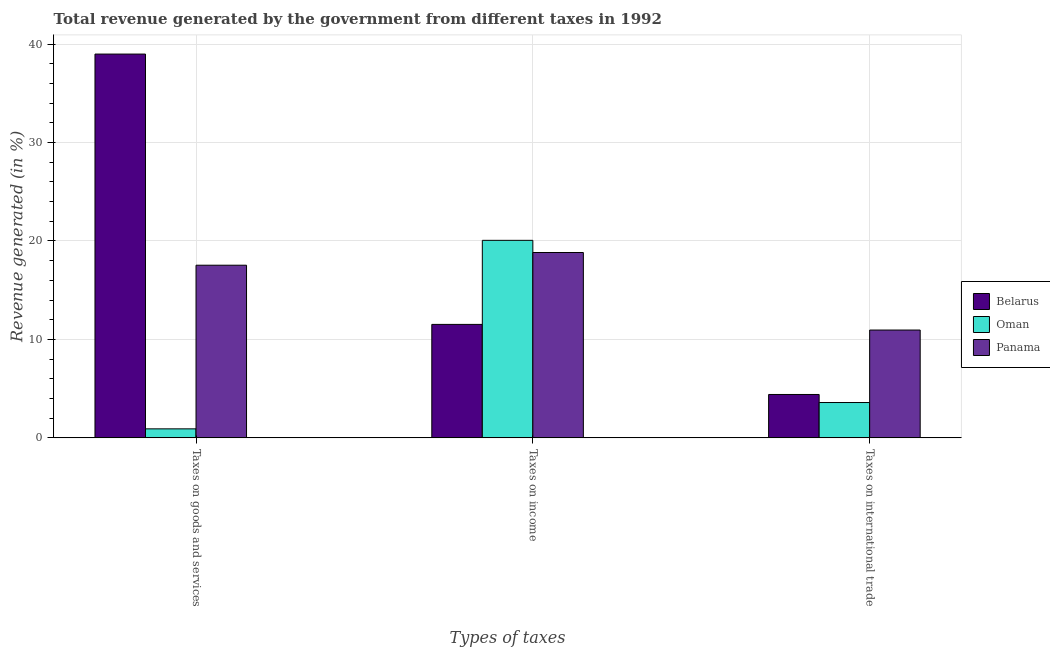How many groups of bars are there?
Make the answer very short. 3. Are the number of bars per tick equal to the number of legend labels?
Ensure brevity in your answer.  Yes. Are the number of bars on each tick of the X-axis equal?
Provide a succinct answer. Yes. What is the label of the 1st group of bars from the left?
Make the answer very short. Taxes on goods and services. What is the percentage of revenue generated by taxes on goods and services in Belarus?
Keep it short and to the point. 38.98. Across all countries, what is the maximum percentage of revenue generated by taxes on income?
Ensure brevity in your answer.  20.06. Across all countries, what is the minimum percentage of revenue generated by taxes on goods and services?
Keep it short and to the point. 0.92. In which country was the percentage of revenue generated by taxes on goods and services maximum?
Give a very brief answer. Belarus. In which country was the percentage of revenue generated by tax on international trade minimum?
Give a very brief answer. Oman. What is the total percentage of revenue generated by tax on international trade in the graph?
Provide a succinct answer. 18.95. What is the difference between the percentage of revenue generated by taxes on goods and services in Belarus and that in Panama?
Your answer should be compact. 21.45. What is the difference between the percentage of revenue generated by taxes on goods and services in Oman and the percentage of revenue generated by tax on international trade in Panama?
Give a very brief answer. -10.04. What is the average percentage of revenue generated by taxes on income per country?
Give a very brief answer. 16.81. What is the difference between the percentage of revenue generated by taxes on goods and services and percentage of revenue generated by tax on international trade in Oman?
Keep it short and to the point. -2.67. What is the ratio of the percentage of revenue generated by taxes on goods and services in Oman to that in Panama?
Give a very brief answer. 0.05. Is the difference between the percentage of revenue generated by taxes on goods and services in Belarus and Oman greater than the difference between the percentage of revenue generated by tax on international trade in Belarus and Oman?
Keep it short and to the point. Yes. What is the difference between the highest and the second highest percentage of revenue generated by taxes on income?
Offer a terse response. 1.24. What is the difference between the highest and the lowest percentage of revenue generated by tax on international trade?
Offer a terse response. 7.36. Is the sum of the percentage of revenue generated by tax on international trade in Oman and Panama greater than the maximum percentage of revenue generated by taxes on income across all countries?
Make the answer very short. No. What does the 3rd bar from the left in Taxes on international trade represents?
Make the answer very short. Panama. What does the 2nd bar from the right in Taxes on international trade represents?
Your answer should be very brief. Oman. What is the difference between two consecutive major ticks on the Y-axis?
Give a very brief answer. 10. Are the values on the major ticks of Y-axis written in scientific E-notation?
Your answer should be very brief. No. Does the graph contain grids?
Provide a short and direct response. Yes. How many legend labels are there?
Your response must be concise. 3. How are the legend labels stacked?
Make the answer very short. Vertical. What is the title of the graph?
Ensure brevity in your answer.  Total revenue generated by the government from different taxes in 1992. What is the label or title of the X-axis?
Provide a short and direct response. Types of taxes. What is the label or title of the Y-axis?
Offer a terse response. Revenue generated (in %). What is the Revenue generated (in %) of Belarus in Taxes on goods and services?
Make the answer very short. 38.98. What is the Revenue generated (in %) of Oman in Taxes on goods and services?
Ensure brevity in your answer.  0.92. What is the Revenue generated (in %) of Panama in Taxes on goods and services?
Ensure brevity in your answer.  17.54. What is the Revenue generated (in %) of Belarus in Taxes on income?
Provide a succinct answer. 11.53. What is the Revenue generated (in %) in Oman in Taxes on income?
Ensure brevity in your answer.  20.06. What is the Revenue generated (in %) in Panama in Taxes on income?
Provide a short and direct response. 18.83. What is the Revenue generated (in %) of Belarus in Taxes on international trade?
Your answer should be compact. 4.41. What is the Revenue generated (in %) in Oman in Taxes on international trade?
Keep it short and to the point. 3.59. What is the Revenue generated (in %) of Panama in Taxes on international trade?
Provide a succinct answer. 10.95. Across all Types of taxes, what is the maximum Revenue generated (in %) of Belarus?
Keep it short and to the point. 38.98. Across all Types of taxes, what is the maximum Revenue generated (in %) in Oman?
Provide a short and direct response. 20.06. Across all Types of taxes, what is the maximum Revenue generated (in %) in Panama?
Provide a short and direct response. 18.83. Across all Types of taxes, what is the minimum Revenue generated (in %) in Belarus?
Your answer should be very brief. 4.41. Across all Types of taxes, what is the minimum Revenue generated (in %) in Oman?
Provide a short and direct response. 0.92. Across all Types of taxes, what is the minimum Revenue generated (in %) in Panama?
Your answer should be compact. 10.95. What is the total Revenue generated (in %) in Belarus in the graph?
Your response must be concise. 54.92. What is the total Revenue generated (in %) in Oman in the graph?
Offer a very short reply. 24.57. What is the total Revenue generated (in %) in Panama in the graph?
Your response must be concise. 47.32. What is the difference between the Revenue generated (in %) of Belarus in Taxes on goods and services and that in Taxes on income?
Provide a succinct answer. 27.46. What is the difference between the Revenue generated (in %) of Oman in Taxes on goods and services and that in Taxes on income?
Your answer should be compact. -19.15. What is the difference between the Revenue generated (in %) in Panama in Taxes on goods and services and that in Taxes on income?
Make the answer very short. -1.29. What is the difference between the Revenue generated (in %) of Belarus in Taxes on goods and services and that in Taxes on international trade?
Offer a terse response. 34.58. What is the difference between the Revenue generated (in %) of Oman in Taxes on goods and services and that in Taxes on international trade?
Provide a short and direct response. -2.67. What is the difference between the Revenue generated (in %) of Panama in Taxes on goods and services and that in Taxes on international trade?
Ensure brevity in your answer.  6.58. What is the difference between the Revenue generated (in %) of Belarus in Taxes on income and that in Taxes on international trade?
Give a very brief answer. 7.12. What is the difference between the Revenue generated (in %) of Oman in Taxes on income and that in Taxes on international trade?
Provide a short and direct response. 16.47. What is the difference between the Revenue generated (in %) of Panama in Taxes on income and that in Taxes on international trade?
Your answer should be very brief. 7.87. What is the difference between the Revenue generated (in %) in Belarus in Taxes on goods and services and the Revenue generated (in %) in Oman in Taxes on income?
Your answer should be very brief. 18.92. What is the difference between the Revenue generated (in %) in Belarus in Taxes on goods and services and the Revenue generated (in %) in Panama in Taxes on income?
Offer a terse response. 20.16. What is the difference between the Revenue generated (in %) of Oman in Taxes on goods and services and the Revenue generated (in %) of Panama in Taxes on income?
Provide a succinct answer. -17.91. What is the difference between the Revenue generated (in %) in Belarus in Taxes on goods and services and the Revenue generated (in %) in Oman in Taxes on international trade?
Your response must be concise. 35.39. What is the difference between the Revenue generated (in %) in Belarus in Taxes on goods and services and the Revenue generated (in %) in Panama in Taxes on international trade?
Your answer should be compact. 28.03. What is the difference between the Revenue generated (in %) of Oman in Taxes on goods and services and the Revenue generated (in %) of Panama in Taxes on international trade?
Ensure brevity in your answer.  -10.04. What is the difference between the Revenue generated (in %) in Belarus in Taxes on income and the Revenue generated (in %) in Oman in Taxes on international trade?
Provide a short and direct response. 7.93. What is the difference between the Revenue generated (in %) in Belarus in Taxes on income and the Revenue generated (in %) in Panama in Taxes on international trade?
Your response must be concise. 0.57. What is the difference between the Revenue generated (in %) of Oman in Taxes on income and the Revenue generated (in %) of Panama in Taxes on international trade?
Ensure brevity in your answer.  9.11. What is the average Revenue generated (in %) in Belarus per Types of taxes?
Give a very brief answer. 18.31. What is the average Revenue generated (in %) of Oman per Types of taxes?
Give a very brief answer. 8.19. What is the average Revenue generated (in %) of Panama per Types of taxes?
Offer a very short reply. 15.77. What is the difference between the Revenue generated (in %) in Belarus and Revenue generated (in %) in Oman in Taxes on goods and services?
Offer a very short reply. 38.07. What is the difference between the Revenue generated (in %) of Belarus and Revenue generated (in %) of Panama in Taxes on goods and services?
Provide a succinct answer. 21.45. What is the difference between the Revenue generated (in %) of Oman and Revenue generated (in %) of Panama in Taxes on goods and services?
Provide a short and direct response. -16.62. What is the difference between the Revenue generated (in %) of Belarus and Revenue generated (in %) of Oman in Taxes on income?
Provide a short and direct response. -8.54. What is the difference between the Revenue generated (in %) in Belarus and Revenue generated (in %) in Panama in Taxes on income?
Provide a short and direct response. -7.3. What is the difference between the Revenue generated (in %) of Oman and Revenue generated (in %) of Panama in Taxes on income?
Make the answer very short. 1.24. What is the difference between the Revenue generated (in %) in Belarus and Revenue generated (in %) in Oman in Taxes on international trade?
Make the answer very short. 0.82. What is the difference between the Revenue generated (in %) of Belarus and Revenue generated (in %) of Panama in Taxes on international trade?
Provide a succinct answer. -6.55. What is the difference between the Revenue generated (in %) in Oman and Revenue generated (in %) in Panama in Taxes on international trade?
Your answer should be compact. -7.36. What is the ratio of the Revenue generated (in %) of Belarus in Taxes on goods and services to that in Taxes on income?
Provide a succinct answer. 3.38. What is the ratio of the Revenue generated (in %) in Oman in Taxes on goods and services to that in Taxes on income?
Ensure brevity in your answer.  0.05. What is the ratio of the Revenue generated (in %) in Panama in Taxes on goods and services to that in Taxes on income?
Offer a terse response. 0.93. What is the ratio of the Revenue generated (in %) in Belarus in Taxes on goods and services to that in Taxes on international trade?
Provide a short and direct response. 8.85. What is the ratio of the Revenue generated (in %) of Oman in Taxes on goods and services to that in Taxes on international trade?
Make the answer very short. 0.26. What is the ratio of the Revenue generated (in %) in Panama in Taxes on goods and services to that in Taxes on international trade?
Offer a terse response. 1.6. What is the ratio of the Revenue generated (in %) in Belarus in Taxes on income to that in Taxes on international trade?
Offer a very short reply. 2.62. What is the ratio of the Revenue generated (in %) in Oman in Taxes on income to that in Taxes on international trade?
Offer a terse response. 5.59. What is the ratio of the Revenue generated (in %) of Panama in Taxes on income to that in Taxes on international trade?
Your answer should be compact. 1.72. What is the difference between the highest and the second highest Revenue generated (in %) of Belarus?
Provide a short and direct response. 27.46. What is the difference between the highest and the second highest Revenue generated (in %) of Oman?
Provide a succinct answer. 16.47. What is the difference between the highest and the second highest Revenue generated (in %) in Panama?
Provide a short and direct response. 1.29. What is the difference between the highest and the lowest Revenue generated (in %) in Belarus?
Provide a short and direct response. 34.58. What is the difference between the highest and the lowest Revenue generated (in %) in Oman?
Make the answer very short. 19.15. What is the difference between the highest and the lowest Revenue generated (in %) of Panama?
Provide a short and direct response. 7.87. 